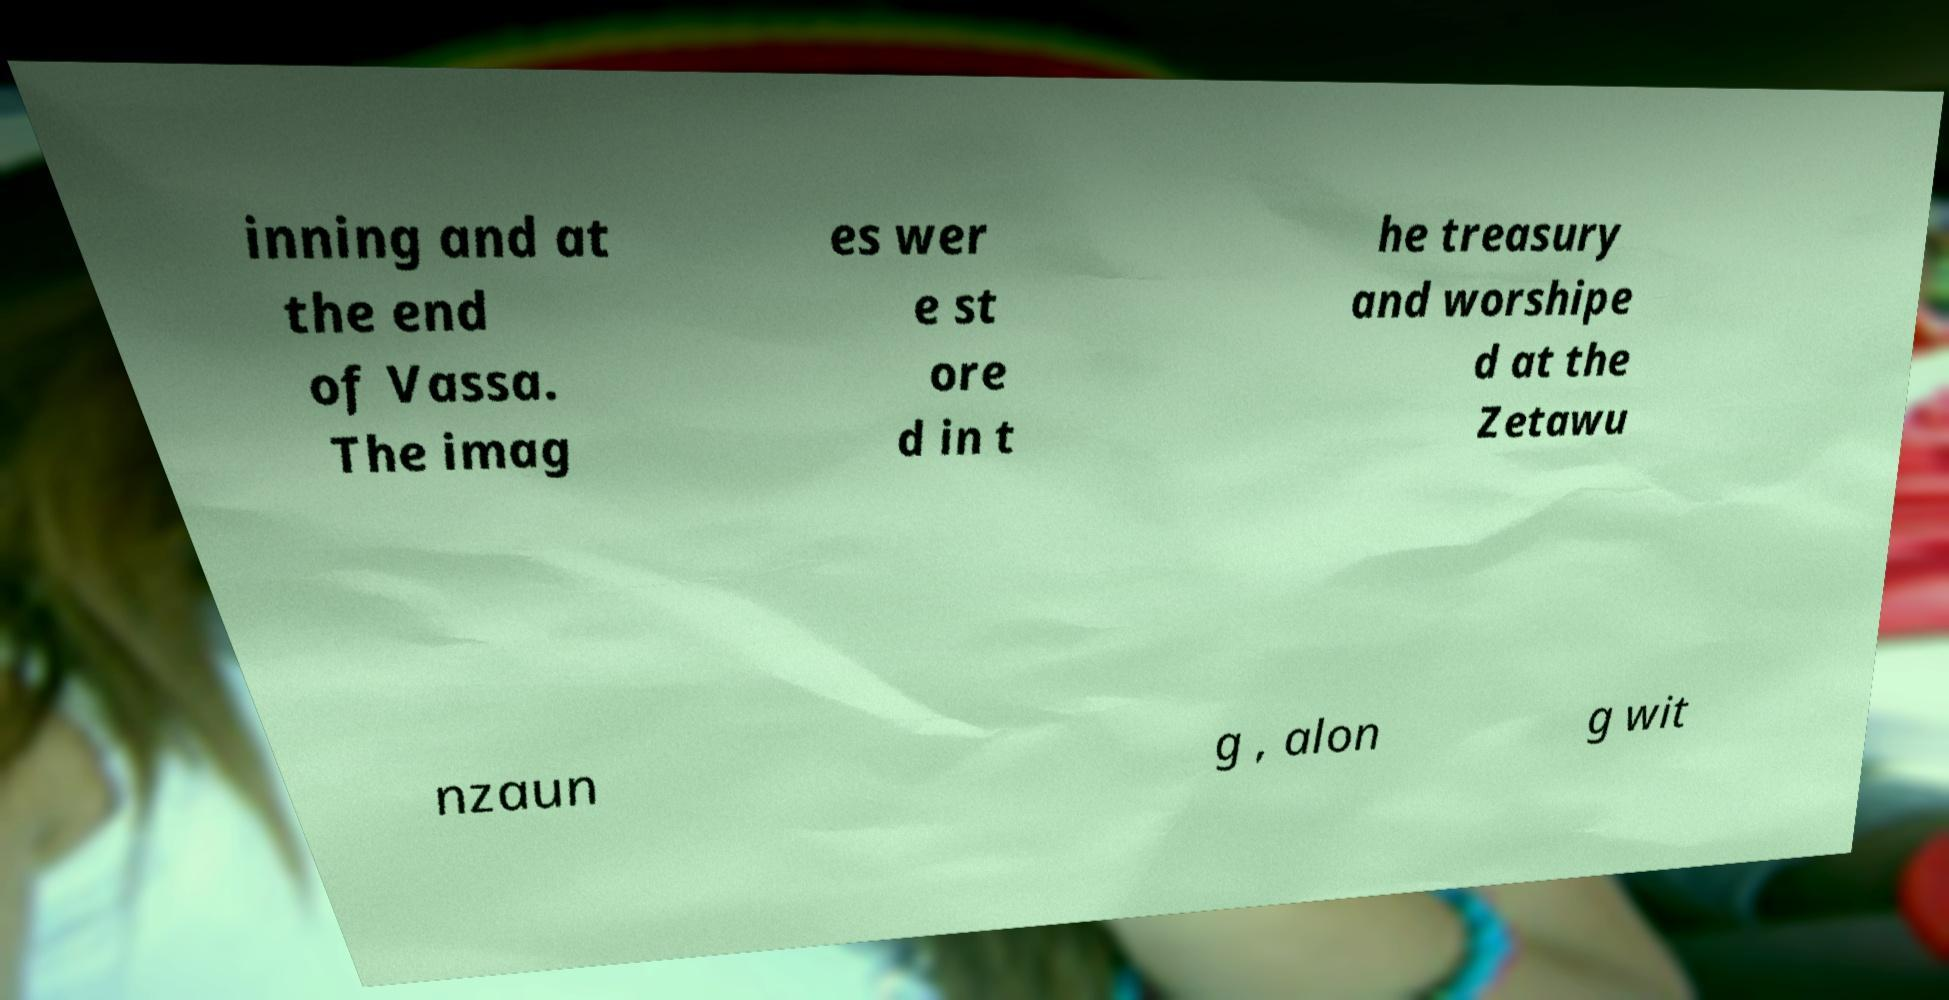I need the written content from this picture converted into text. Can you do that? inning and at the end of Vassa. The imag es wer e st ore d in t he treasury and worshipe d at the Zetawu nzaun g , alon g wit 